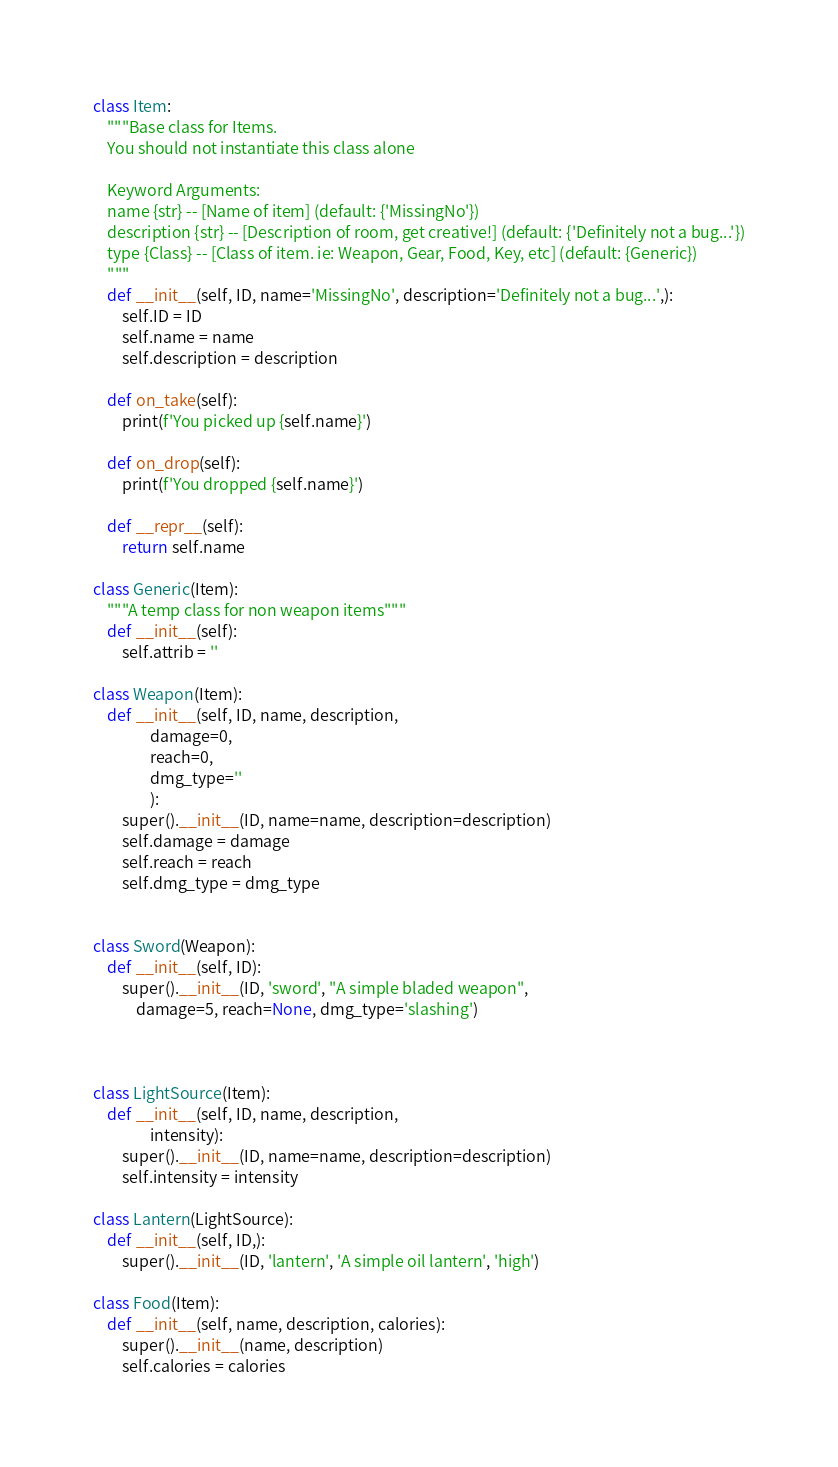Convert code to text. <code><loc_0><loc_0><loc_500><loc_500><_Python_>
class Item:
    """Base class for Items.
    You should not instantiate this class alone

    Keyword Arguments:
    name {str} -- [Name of item] (default: {'MissingNo'})
    description {str} -- [Description of room, get creative!] (default: {'Definitely not a bug...'})
    type {Class} -- [Class of item. ie: Weapon, Gear, Food, Key, etc] (default: {Generic})
    """
    def __init__(self, ID, name='MissingNo', description='Definitely not a bug...',):
        self.ID = ID
        self.name = name
        self.description = description

    def on_take(self):
        print(f'You picked up {self.name}')
    
    def on_drop(self):
        print(f'You dropped {self.name}')

    def __repr__(self):
        return self.name

class Generic(Item):
    """A temp class for non weapon items"""
    def __init__(self):
        self.attrib = ''

class Weapon(Item):
    def __init__(self, ID, name, description,
                damage=0,
                reach=0,
                dmg_type=''
                ):
        super().__init__(ID, name=name, description=description)
        self.damage = damage
        self.reach = reach
        self.dmg_type = dmg_type


class Sword(Weapon):
    def __init__(self, ID):
        super().__init__(ID, 'sword', "A simple bladed weapon", 
            damage=5, reach=None, dmg_type='slashing')



class LightSource(Item):
    def __init__(self, ID, name, description,
                intensity):
        super().__init__(ID, name=name, description=description)
        self.intensity = intensity

class Lantern(LightSource):
    def __init__(self, ID,):
        super().__init__(ID, 'lantern', 'A simple oil lantern', 'high')

class Food(Item):
    def __init__(self, name, description, calories):
        super().__init__(name, description)
        self.calories = calories


</code> 